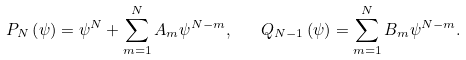Convert formula to latex. <formula><loc_0><loc_0><loc_500><loc_500>P _ { N } \left ( \psi \right ) = \psi ^ { N } + \sum _ { m = 1 } ^ { N } A _ { m } \psi ^ { N - m } , \quad Q _ { N - 1 } \left ( \psi \right ) = \sum _ { m = 1 } ^ { N } B _ { m } \psi ^ { N - m } .</formula> 